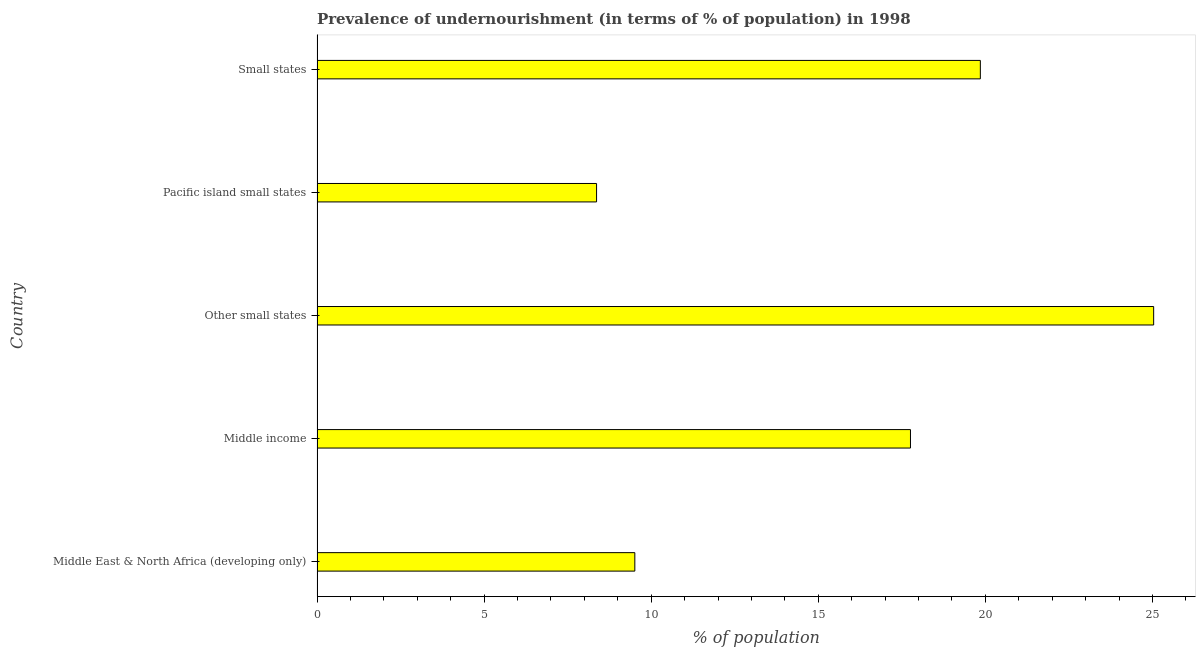Does the graph contain grids?
Provide a succinct answer. No. What is the title of the graph?
Your response must be concise. Prevalence of undernourishment (in terms of % of population) in 1998. What is the label or title of the X-axis?
Give a very brief answer. % of population. What is the label or title of the Y-axis?
Offer a terse response. Country. What is the percentage of undernourished population in Pacific island small states?
Provide a succinct answer. 8.36. Across all countries, what is the maximum percentage of undernourished population?
Your answer should be very brief. 25.04. Across all countries, what is the minimum percentage of undernourished population?
Your answer should be very brief. 8.36. In which country was the percentage of undernourished population maximum?
Your answer should be very brief. Other small states. In which country was the percentage of undernourished population minimum?
Your answer should be compact. Pacific island small states. What is the sum of the percentage of undernourished population?
Offer a very short reply. 80.52. What is the difference between the percentage of undernourished population in Middle East & North Africa (developing only) and Small states?
Provide a short and direct response. -10.34. What is the average percentage of undernourished population per country?
Your answer should be compact. 16.1. What is the median percentage of undernourished population?
Your response must be concise. 17.76. In how many countries, is the percentage of undernourished population greater than 10 %?
Your answer should be very brief. 3. What is the ratio of the percentage of undernourished population in Middle income to that in Other small states?
Provide a succinct answer. 0.71. What is the difference between the highest and the second highest percentage of undernourished population?
Offer a very short reply. 5.19. Is the sum of the percentage of undernourished population in Middle income and Other small states greater than the maximum percentage of undernourished population across all countries?
Your answer should be compact. Yes. What is the difference between the highest and the lowest percentage of undernourished population?
Your answer should be compact. 16.67. In how many countries, is the percentage of undernourished population greater than the average percentage of undernourished population taken over all countries?
Provide a short and direct response. 3. How many bars are there?
Your response must be concise. 5. Are all the bars in the graph horizontal?
Offer a very short reply. Yes. Are the values on the major ticks of X-axis written in scientific E-notation?
Your answer should be very brief. No. What is the % of population of Middle East & North Africa (developing only)?
Provide a succinct answer. 9.51. What is the % of population of Middle income?
Make the answer very short. 17.76. What is the % of population of Other small states?
Your answer should be compact. 25.04. What is the % of population of Pacific island small states?
Provide a short and direct response. 8.36. What is the % of population in Small states?
Keep it short and to the point. 19.85. What is the difference between the % of population in Middle East & North Africa (developing only) and Middle income?
Your answer should be very brief. -8.25. What is the difference between the % of population in Middle East & North Africa (developing only) and Other small states?
Ensure brevity in your answer.  -15.53. What is the difference between the % of population in Middle East & North Africa (developing only) and Pacific island small states?
Ensure brevity in your answer.  1.14. What is the difference between the % of population in Middle East & North Africa (developing only) and Small states?
Provide a succinct answer. -10.34. What is the difference between the % of population in Middle income and Other small states?
Keep it short and to the point. -7.28. What is the difference between the % of population in Middle income and Pacific island small states?
Your response must be concise. 9.39. What is the difference between the % of population in Middle income and Small states?
Your answer should be compact. -2.09. What is the difference between the % of population in Other small states and Pacific island small states?
Keep it short and to the point. 16.67. What is the difference between the % of population in Other small states and Small states?
Ensure brevity in your answer.  5.19. What is the difference between the % of population in Pacific island small states and Small states?
Your answer should be very brief. -11.48. What is the ratio of the % of population in Middle East & North Africa (developing only) to that in Middle income?
Keep it short and to the point. 0.54. What is the ratio of the % of population in Middle East & North Africa (developing only) to that in Other small states?
Give a very brief answer. 0.38. What is the ratio of the % of population in Middle East & North Africa (developing only) to that in Pacific island small states?
Make the answer very short. 1.14. What is the ratio of the % of population in Middle East & North Africa (developing only) to that in Small states?
Offer a terse response. 0.48. What is the ratio of the % of population in Middle income to that in Other small states?
Your answer should be very brief. 0.71. What is the ratio of the % of population in Middle income to that in Pacific island small states?
Offer a terse response. 2.12. What is the ratio of the % of population in Middle income to that in Small states?
Ensure brevity in your answer.  0.9. What is the ratio of the % of population in Other small states to that in Pacific island small states?
Keep it short and to the point. 2.99. What is the ratio of the % of population in Other small states to that in Small states?
Give a very brief answer. 1.26. What is the ratio of the % of population in Pacific island small states to that in Small states?
Provide a short and direct response. 0.42. 